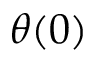<formula> <loc_0><loc_0><loc_500><loc_500>\theta ( 0 )</formula> 